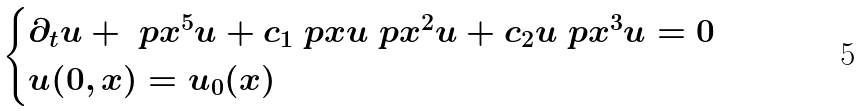Convert formula to latex. <formula><loc_0><loc_0><loc_500><loc_500>\begin{cases} \partial _ { t } u + \ p x ^ { 5 } u + c _ { 1 } \ p x u \ p x ^ { 2 } u + c _ { 2 } u \ p x ^ { 3 } u = 0 \\ u ( 0 , x ) = u _ { 0 } ( x ) \end{cases}</formula> 